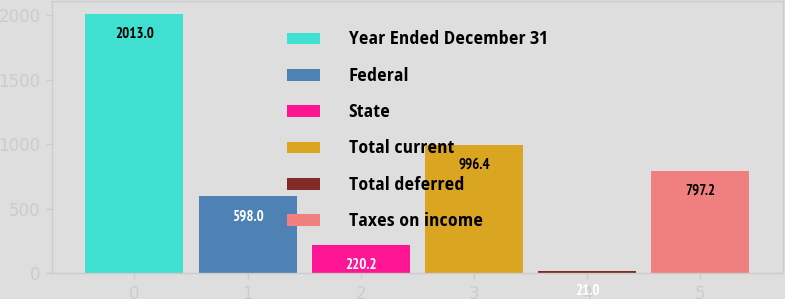<chart> <loc_0><loc_0><loc_500><loc_500><bar_chart><fcel>Year Ended December 31<fcel>Federal<fcel>State<fcel>Total current<fcel>Total deferred<fcel>Taxes on income<nl><fcel>2013<fcel>598<fcel>220.2<fcel>996.4<fcel>21<fcel>797.2<nl></chart> 